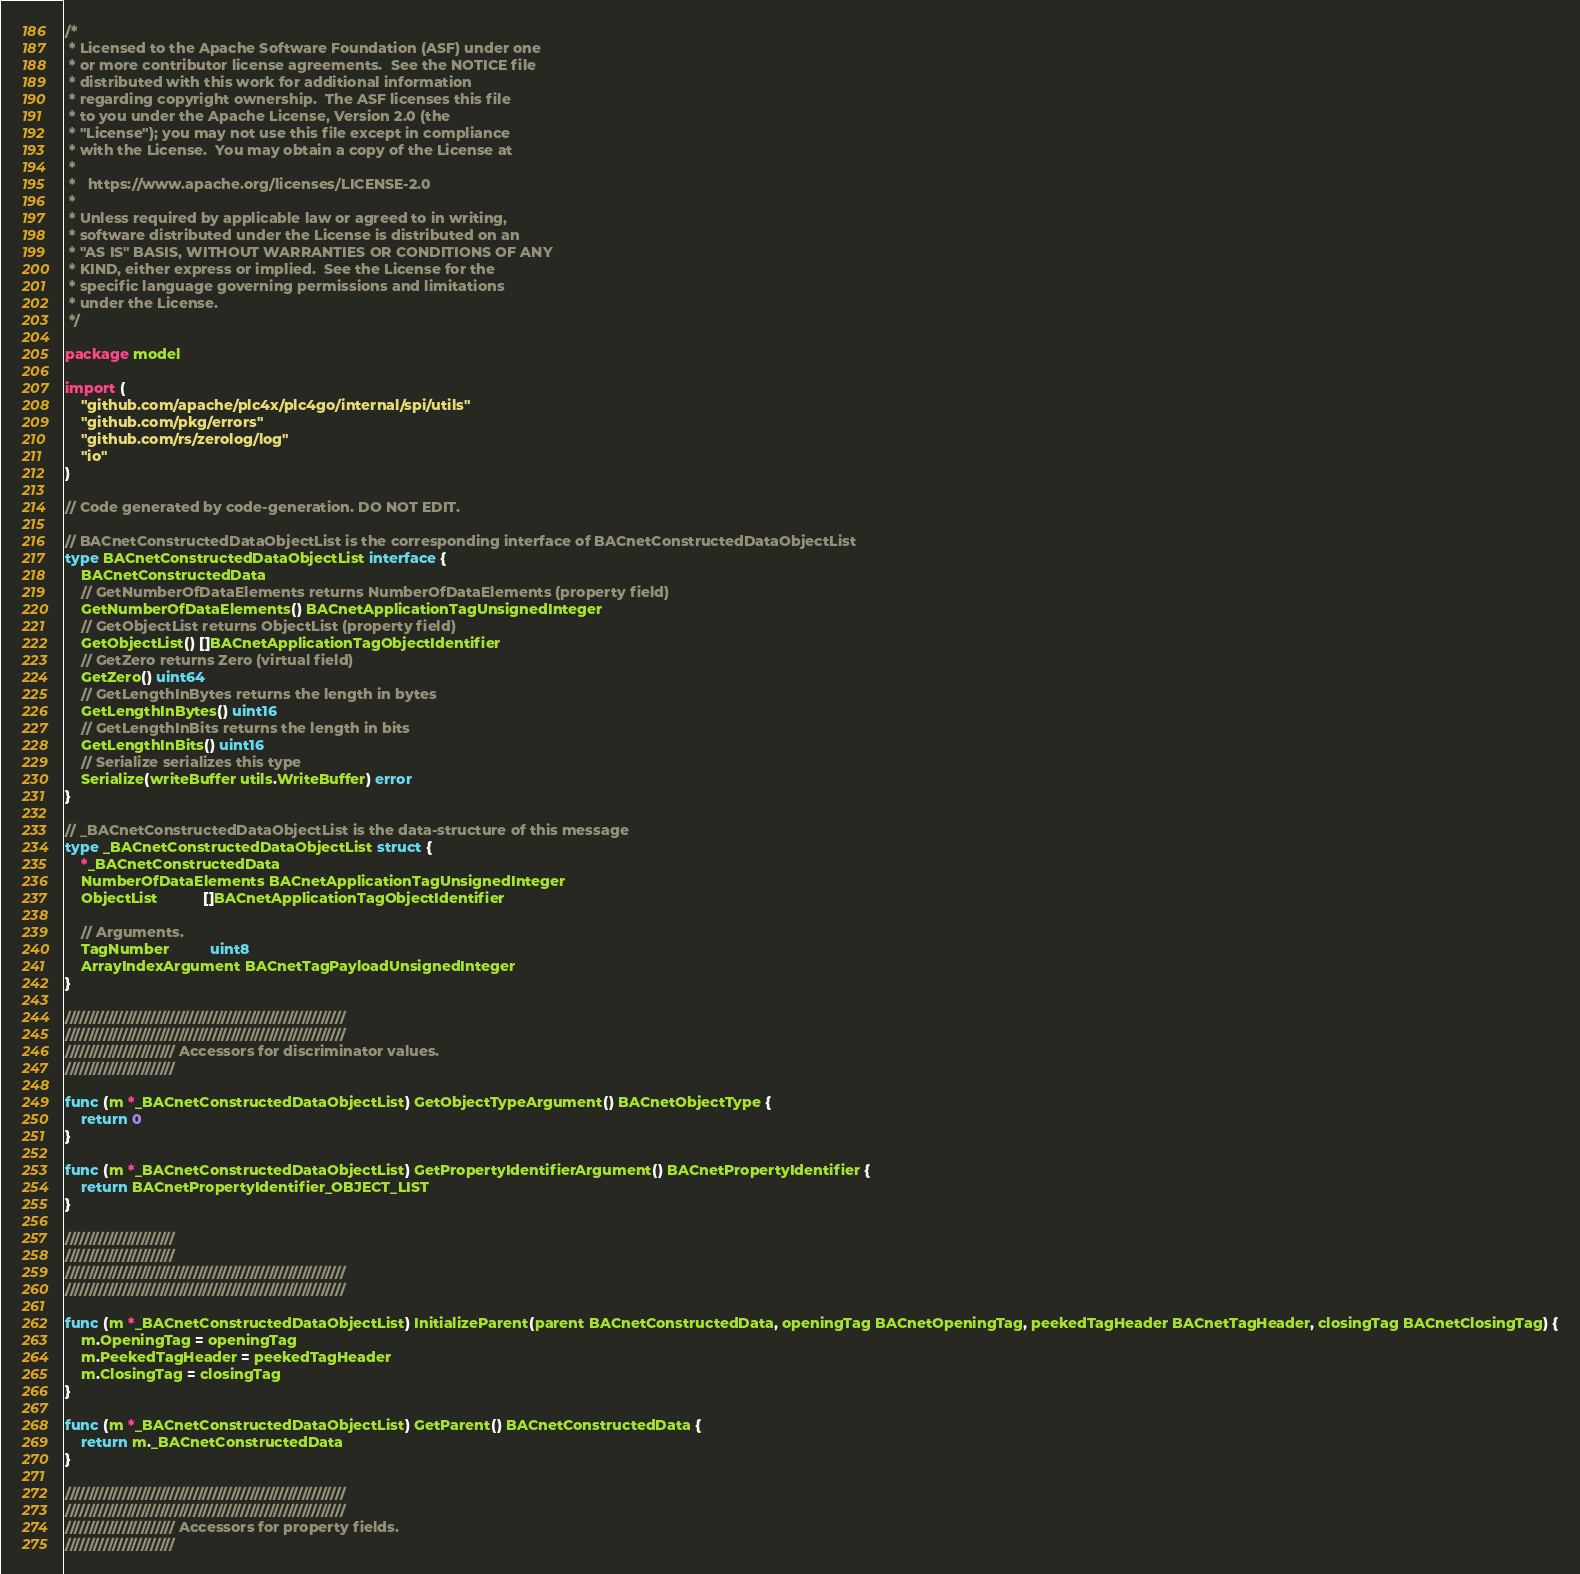<code> <loc_0><loc_0><loc_500><loc_500><_Go_>/*
 * Licensed to the Apache Software Foundation (ASF) under one
 * or more contributor license agreements.  See the NOTICE file
 * distributed with this work for additional information
 * regarding copyright ownership.  The ASF licenses this file
 * to you under the Apache License, Version 2.0 (the
 * "License"); you may not use this file except in compliance
 * with the License.  You may obtain a copy of the License at
 *
 *   https://www.apache.org/licenses/LICENSE-2.0
 *
 * Unless required by applicable law or agreed to in writing,
 * software distributed under the License is distributed on an
 * "AS IS" BASIS, WITHOUT WARRANTIES OR CONDITIONS OF ANY
 * KIND, either express or implied.  See the License for the
 * specific language governing permissions and limitations
 * under the License.
 */

package model

import (
	"github.com/apache/plc4x/plc4go/internal/spi/utils"
	"github.com/pkg/errors"
	"github.com/rs/zerolog/log"
	"io"
)

// Code generated by code-generation. DO NOT EDIT.

// BACnetConstructedDataObjectList is the corresponding interface of BACnetConstructedDataObjectList
type BACnetConstructedDataObjectList interface {
	BACnetConstructedData
	// GetNumberOfDataElements returns NumberOfDataElements (property field)
	GetNumberOfDataElements() BACnetApplicationTagUnsignedInteger
	// GetObjectList returns ObjectList (property field)
	GetObjectList() []BACnetApplicationTagObjectIdentifier
	// GetZero returns Zero (virtual field)
	GetZero() uint64
	// GetLengthInBytes returns the length in bytes
	GetLengthInBytes() uint16
	// GetLengthInBits returns the length in bits
	GetLengthInBits() uint16
	// Serialize serializes this type
	Serialize(writeBuffer utils.WriteBuffer) error
}

// _BACnetConstructedDataObjectList is the data-structure of this message
type _BACnetConstructedDataObjectList struct {
	*_BACnetConstructedData
	NumberOfDataElements BACnetApplicationTagUnsignedInteger
	ObjectList           []BACnetApplicationTagObjectIdentifier

	// Arguments.
	TagNumber          uint8
	ArrayIndexArgument BACnetTagPayloadUnsignedInteger
}

///////////////////////////////////////////////////////////
///////////////////////////////////////////////////////////
/////////////////////// Accessors for discriminator values.
///////////////////////

func (m *_BACnetConstructedDataObjectList) GetObjectTypeArgument() BACnetObjectType {
	return 0
}

func (m *_BACnetConstructedDataObjectList) GetPropertyIdentifierArgument() BACnetPropertyIdentifier {
	return BACnetPropertyIdentifier_OBJECT_LIST
}

///////////////////////
///////////////////////
///////////////////////////////////////////////////////////
///////////////////////////////////////////////////////////

func (m *_BACnetConstructedDataObjectList) InitializeParent(parent BACnetConstructedData, openingTag BACnetOpeningTag, peekedTagHeader BACnetTagHeader, closingTag BACnetClosingTag) {
	m.OpeningTag = openingTag
	m.PeekedTagHeader = peekedTagHeader
	m.ClosingTag = closingTag
}

func (m *_BACnetConstructedDataObjectList) GetParent() BACnetConstructedData {
	return m._BACnetConstructedData
}

///////////////////////////////////////////////////////////
///////////////////////////////////////////////////////////
/////////////////////// Accessors for property fields.
///////////////////////
</code> 